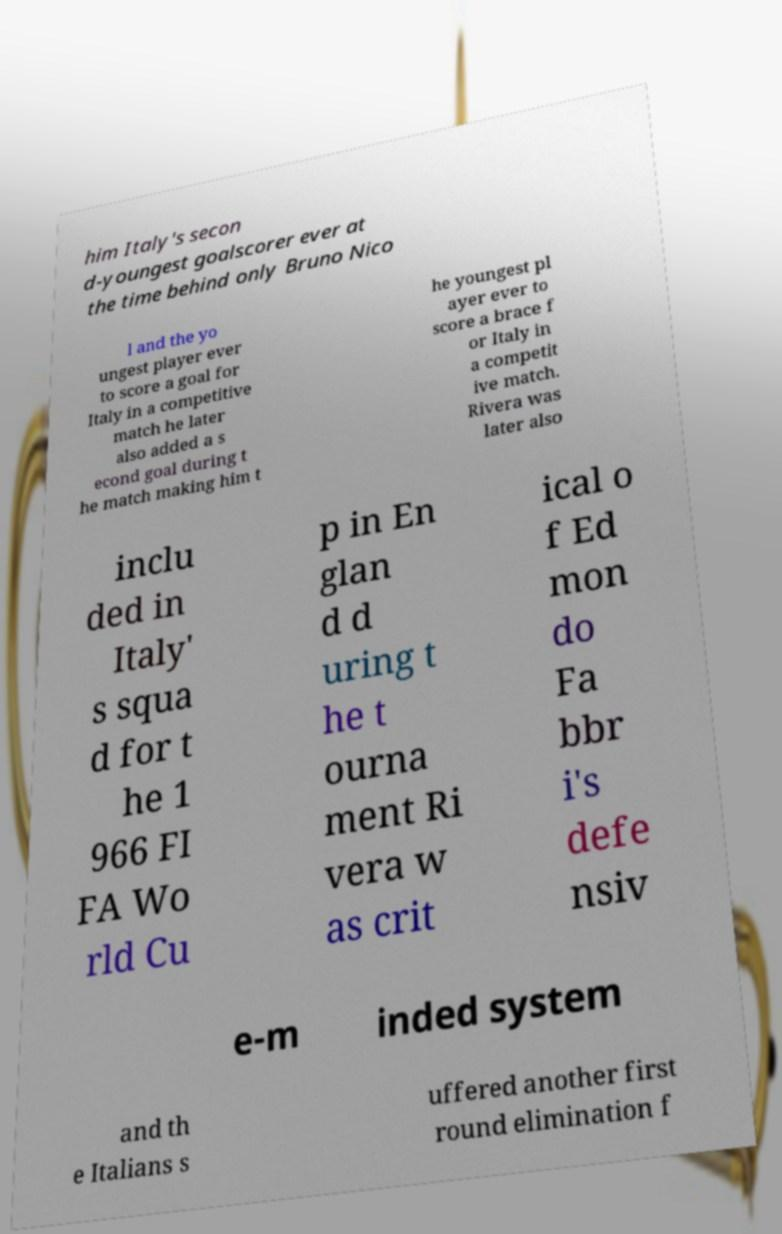Please identify and transcribe the text found in this image. him Italy's secon d-youngest goalscorer ever at the time behind only Bruno Nico l and the yo ungest player ever to score a goal for Italy in a competitive match he later also added a s econd goal during t he match making him t he youngest pl ayer ever to score a brace f or Italy in a competit ive match. Rivera was later also inclu ded in Italy' s squa d for t he 1 966 FI FA Wo rld Cu p in En glan d d uring t he t ourna ment Ri vera w as crit ical o f Ed mon do Fa bbr i's defe nsiv e-m inded system and th e Italians s uffered another first round elimination f 